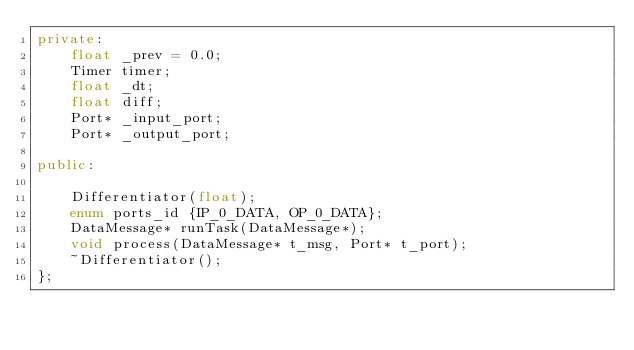<code> <loc_0><loc_0><loc_500><loc_500><_C++_>private:
    float _prev = 0.0;
    Timer timer;
    float _dt;
    float diff;
    Port* _input_port;
    Port* _output_port;
   
public:
    
    Differentiator(float);
    enum ports_id {IP_0_DATA, OP_0_DATA};
    DataMessage* runTask(DataMessage*);
    void process(DataMessage* t_msg, Port* t_port);
    ~Differentiator();
};</code> 